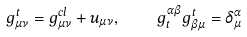Convert formula to latex. <formula><loc_0><loc_0><loc_500><loc_500>g ^ { t } _ { \mu \nu } = g ^ { c l } _ { \mu \nu } + u _ { \mu \nu } , \quad g _ { t } ^ { \alpha \beta } g ^ { t } _ { \beta \mu } = \delta ^ { \alpha } _ { \mu }</formula> 